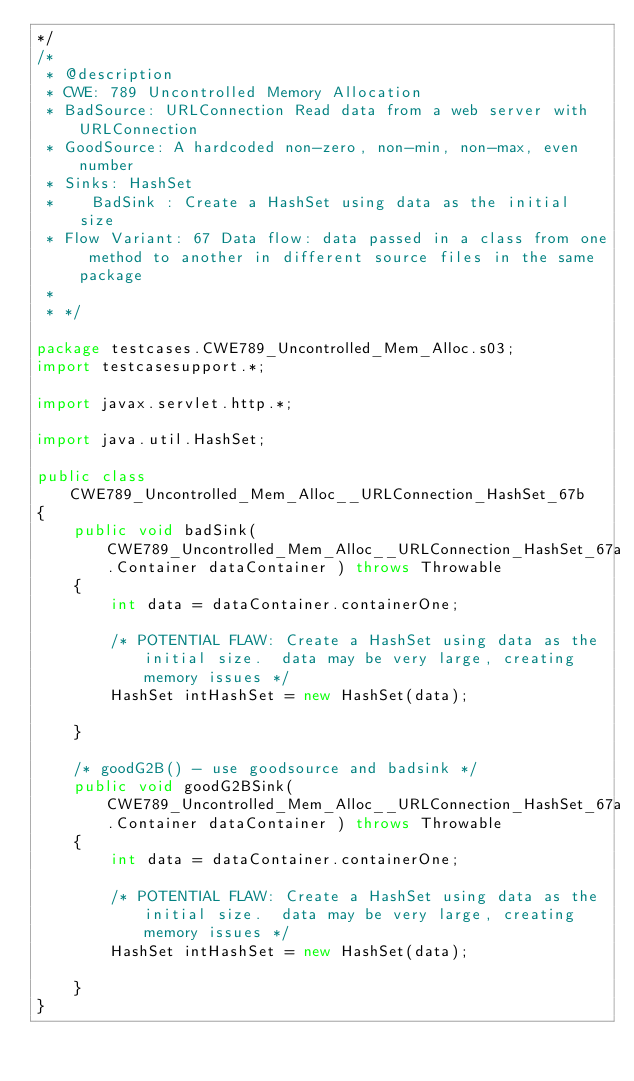<code> <loc_0><loc_0><loc_500><loc_500><_Java_>*/
/*
 * @description
 * CWE: 789 Uncontrolled Memory Allocation
 * BadSource: URLConnection Read data from a web server with URLConnection
 * GoodSource: A hardcoded non-zero, non-min, non-max, even number
 * Sinks: HashSet
 *    BadSink : Create a HashSet using data as the initial size
 * Flow Variant: 67 Data flow: data passed in a class from one method to another in different source files in the same package
 *
 * */

package testcases.CWE789_Uncontrolled_Mem_Alloc.s03;
import testcasesupport.*;

import javax.servlet.http.*;

import java.util.HashSet;

public class CWE789_Uncontrolled_Mem_Alloc__URLConnection_HashSet_67b
{
    public void badSink(CWE789_Uncontrolled_Mem_Alloc__URLConnection_HashSet_67a.Container dataContainer ) throws Throwable
    {
        int data = dataContainer.containerOne;

        /* POTENTIAL FLAW: Create a HashSet using data as the initial size.  data may be very large, creating memory issues */
        HashSet intHashSet = new HashSet(data);

    }

    /* goodG2B() - use goodsource and badsink */
    public void goodG2BSink(CWE789_Uncontrolled_Mem_Alloc__URLConnection_HashSet_67a.Container dataContainer ) throws Throwable
    {
        int data = dataContainer.containerOne;

        /* POTENTIAL FLAW: Create a HashSet using data as the initial size.  data may be very large, creating memory issues */
        HashSet intHashSet = new HashSet(data);

    }
}
</code> 